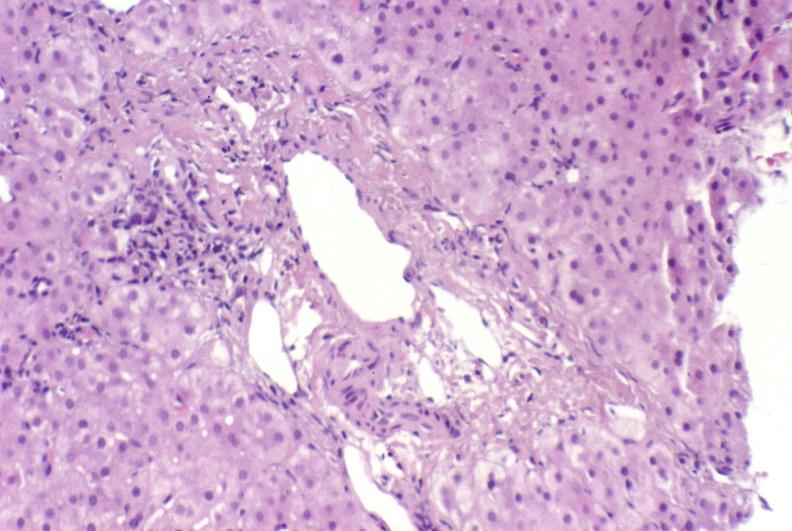does this image show ductopenia?
Answer the question using a single word or phrase. Yes 